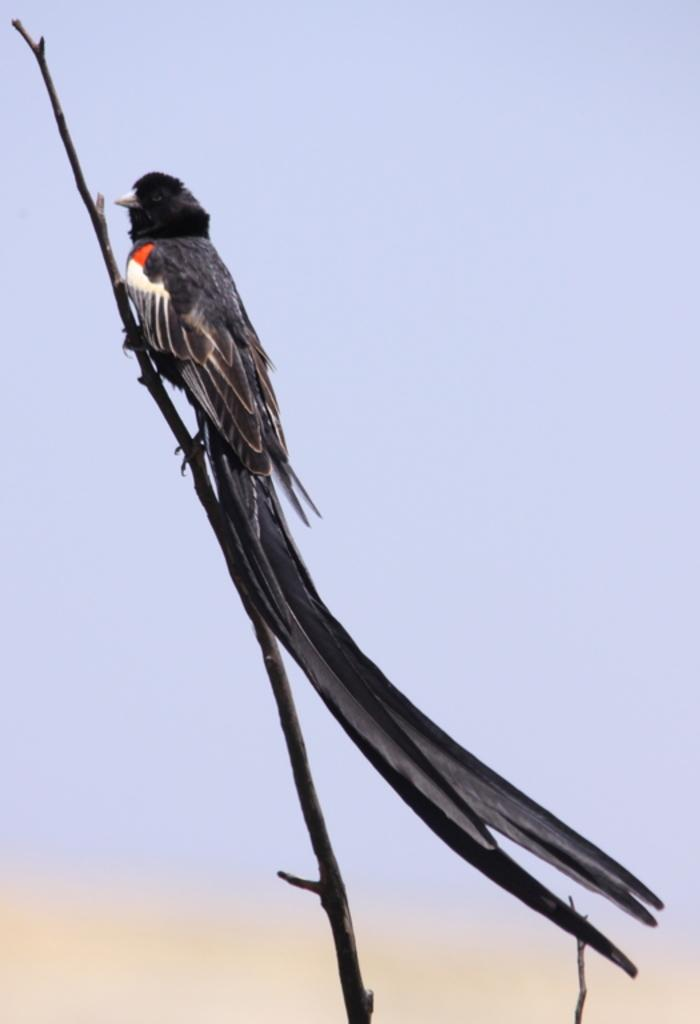What type of animal is in the image? There is a bird in the image. How is the bird positioned in the image? The bird is standing by holding a branch of a tree. What color is the background of the image? The background of the image is blue. What type of chain is the bird using to climb the tree in the image? There is no chain present in the image; the bird is holding a branch of a tree. 